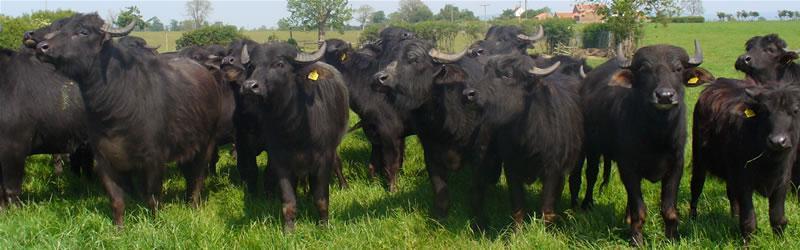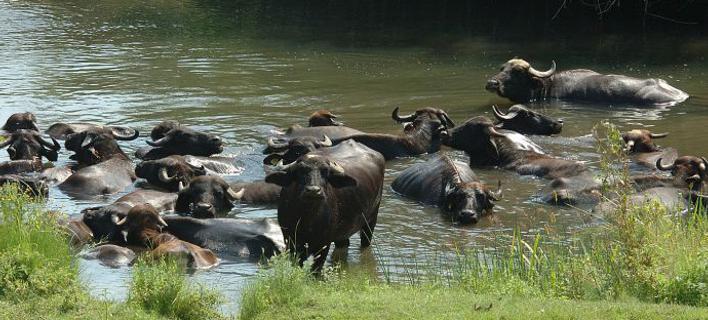The first image is the image on the left, the second image is the image on the right. Analyze the images presented: Is the assertion "At least one image includes a water buffalo in chin-deep water, and the left image includes water buffalo and green grass." valid? Answer yes or no. Yes. The first image is the image on the left, the second image is the image on the right. Assess this claim about the two images: "Some water buffalos are in the water.". Correct or not? Answer yes or no. Yes. 